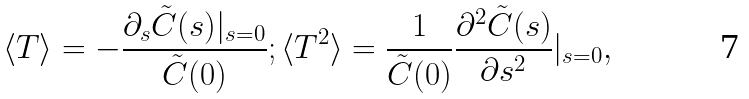<formula> <loc_0><loc_0><loc_500><loc_500>\langle T \rangle = - \frac { \partial _ { s } { \tilde { C } } ( s ) | _ { s = 0 } } { { \tilde { C } } ( 0 ) } ; \langle T ^ { 2 } \rangle = \frac { 1 } { { \tilde { C } } ( 0 ) } \frac { \partial ^ { 2 } { \tilde { C } } ( s ) } { \partial s ^ { 2 } } | _ { s = 0 } ,</formula> 